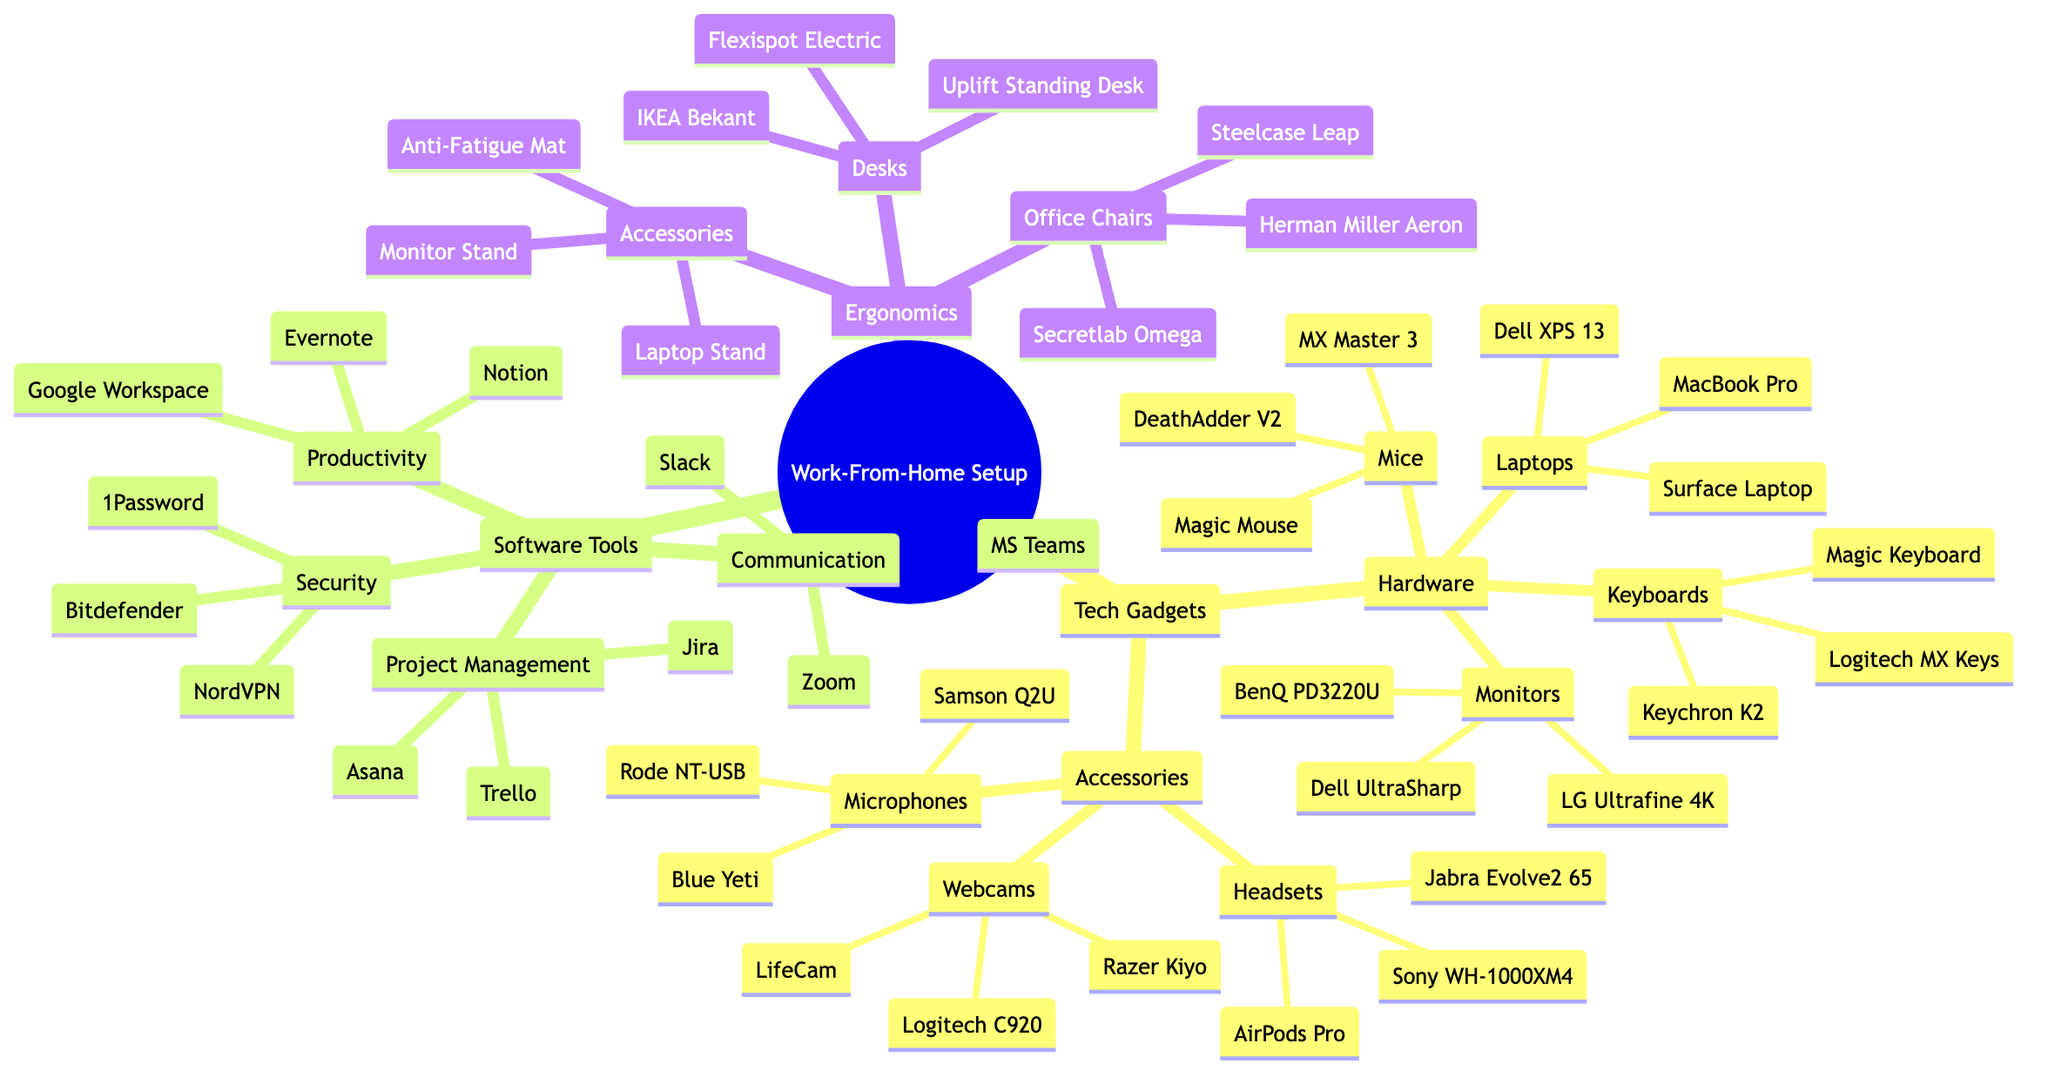What is the root node of the diagram? The root node is labeled at the top of the mind map and represents the main topic being discussed, which is “Efficient Work-From-Home Setup.”
Answer: Efficient Work-From-Home Setup How many main categories are listed under Tech Gadgets? The diagram divides Tech Gadgets into two main categories: Hardware and Accessories, which amounts to a total of two main categories.
Answer: 2 What is the name of one microphone listed under Accessories? The list of microphones under Accessories includes items like Blue Yeti, Rode NT-USB, and Samson Q2U; Blue Yeti is one such example.
Answer: Blue Yeti Which software tool is categorized under Project Management? The Project Management section lists tools like Trello, Asana, and Jira; Jira is one of the tools in this category.
Answer: Jira Which ergonomic chair is a competitor to the Steelcase Leap? The Office Chairs section lists Herman Miller Aeron, Steelcase Leap, and Secretlab Omega; Herman Miller Aeron competes with the Steelcase Leap in terms of ergonomic design.
Answer: Herman Miller Aeron How many types of software tools are represented in the diagram? The Software Tools section includes four types: Communication, Project Management, Productivity, and Security; therefore, there are four types listed.
Answer: 4 What are the children nodes under Ergonomics? The Ergonomics section includes three child nodes: Office Chairs, Desks, and Accessories, which signify that Ergonomics covers various aspects of workspace comfort.
Answer: Office Chairs, Desks, Accessories Which accessory can help with video calls? The Accessories section lists webcams, which are explicitly designed to facilitate video calls; Logitech C920 is a specific example from this category.
Answer: Logitech C920 Name an application for productivity listed under Software Tools. Under the Productivity category in the Software Tools section, Notion, Evernote, and Google Workspace are mentioned; Notion is one such application.
Answer: Notion 